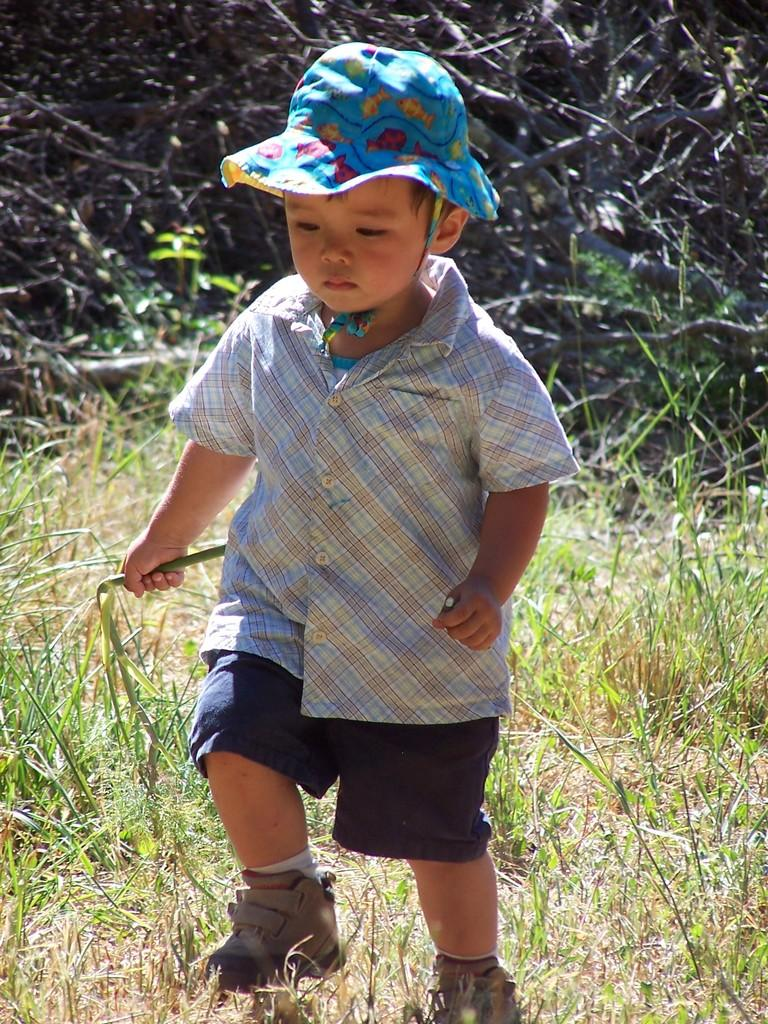Who is the main subject in the image? There is a boy in the image. What is the boy wearing on his head? The boy is wearing a hat. What is the boy holding in his hands? The boy is holding objects. What is the boy doing in the image? The boy is walking on the ground. What can be seen in the background of the image? There are dried trees and plants in the background of the image. What type of vegetation is present on the ground in the image? There is grass on the ground in the image. What type of liquid is the boy drinking in the image? There is no liquid present in the image; the boy is walking and holding objects. 